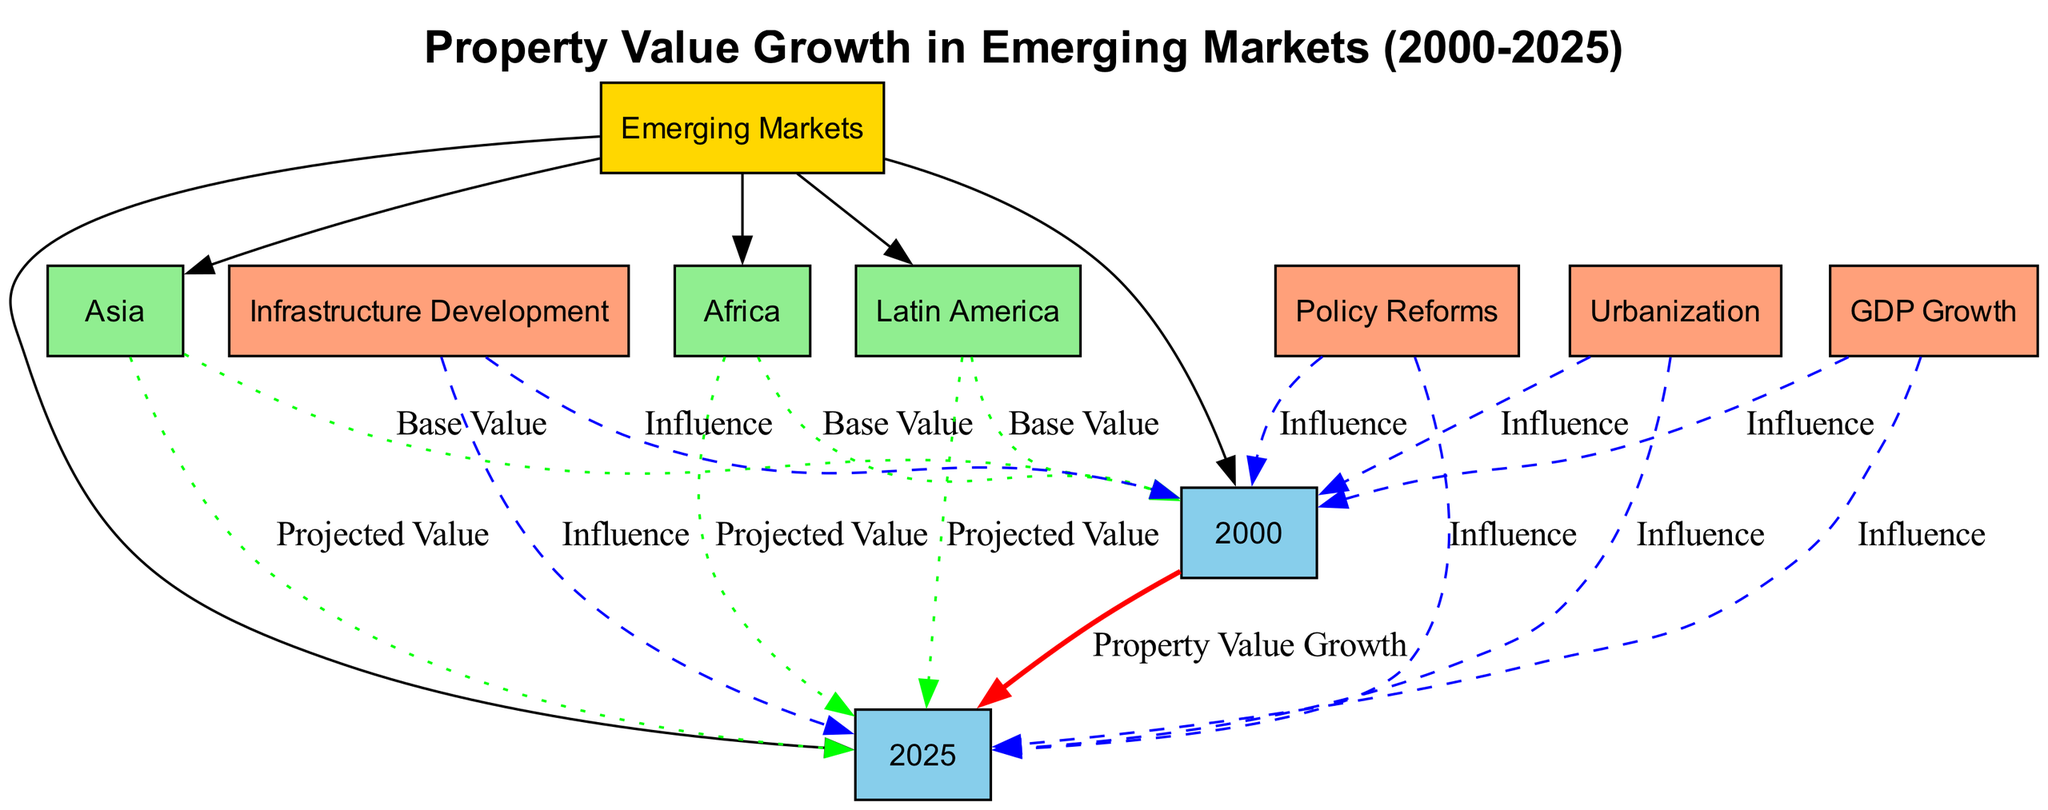What years are compared in the diagram? The diagram compares the years 2000 and 2025, which are represented as linked nodes under the category of Emerging Markets.
Answer: 2000 and 2025 How many regions are represented in the diagram? The diagram includes three regions: Asia, Africa, and Latin America, which are connected to the central category of Emerging Markets.
Answer: Three What does the red edge between 2000 and 2025 indicate? The red edge signifies "Property Value Growth," indicating a directed influence from the base year 2000 to the projected year 2025.
Answer: Property Value Growth What is the influence of GDP Growth on 2025? The diagram shows a dashed blue edge from GDP Growth to 2025 signifying its influence, indicating that the factor contributes to property value growth in 2025.
Answer: Influence Which region has both a base value and a projected value linked to it? All regions (Asia, Africa, Latin America) have both a base value in 2000 and a projected value in 2025, as indicated by dotted edges leading to and from each region to these years.
Answer: Asia, Africa, Latin America How many influencing factors impact both years? There are four influencing factors (GDP Growth, Urbanization, Infrastructure Development, Policy Reforms) that affect property values in both 2000 and 2025, as shown by their connections to these years.
Answer: Four Which factor has the strongest visual emphasis in the diagram? The factor represented by the red edge (Property Value Growth) indicates a direct comparison, highlighting its significance visually as it's more prominent than the dashed lines for other factors.
Answer: Property Value Growth What do the green edges connecting regions to the years represent? The green edges indicate "Base Value" and "Projected Value," showing the values associated with each region in both 2000 and 2025, respectively.
Answer: Base Value and Projected Value Which influencing factor is shown last in the diagram? Policy Reforms is the last influencing factor displayed as it is the last node before connecting to both years in the vertical flow of the diagram.
Answer: Policy Reforms 